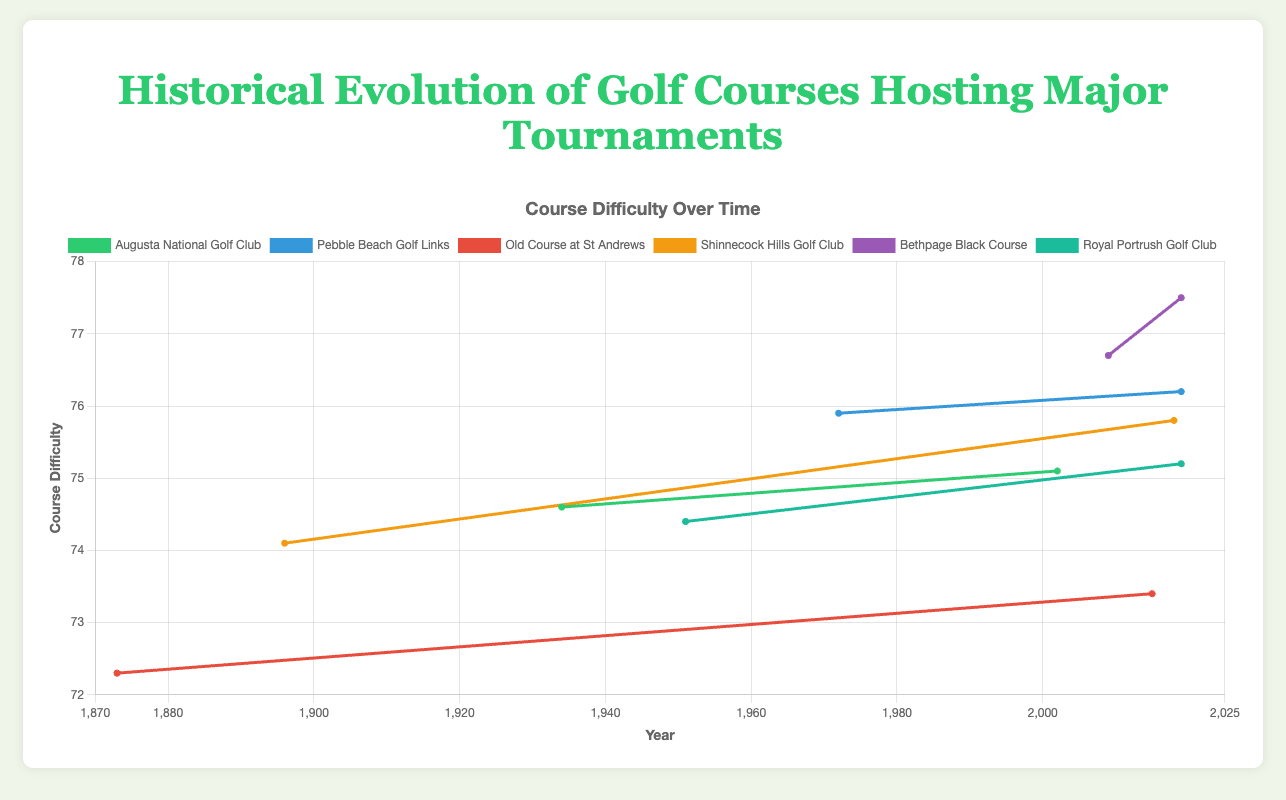What's the average course difficulty of Pebble Beach Golf Links in the years shown? There are two measurements shown for Pebble Beach Golf Links, one in 1972 (75.9) and one in 2019 (76.2). The average is calculated as (75.9 + 76.2) / 2 = 76.05
Answer: 76.05 Which golf course has the highest course difficulty in the data presented? Reviewing the course difficulties of all the courses shown, Bethpage Black Course in 2019 has the highest difficulty with a value of 77.5.
Answer: Bethpage Black Course Between Augusta National Golf Club and Old Course at St Andrews, which had a greater increase in course difficulty between the earliest and latest years shown? For Augusta National: Earliest year shown is 1934 (74.6) and latest is 2002 (75.1). Increase = 75.1 - 74.6 = 0.5; For Old Course: Earliest year shown is 1873 (72.3) and latest is 2015 (73.4). Increase = 73.4 - 72.3 = 1.1. Old Course had a greater increase.
Answer: Old Course at St Andrews How many renovations occurred for courses hosting the U.S. Open between 2000 and 2020? Reviewing the dataset: Pebble Beach (2018), Shinnecock Hills (2016), and Bethpage Black (2007) had renovations in this timeline. This totals to 3 renovations.
Answer: 3 In what year did the Old Course at St Andrews undergo renovation and host The Open Championship in the same year? Reviewing the dataset, the Old Course at St Andrews hosted The Open in 2015, but was last renovated in 2012, so no such year exists where both events occurred in the same year.
Answer: None Which tournament held on Augusta National Golf Club had a higher course difficulty: The Masters in 1934 or 2002? Comparing the course difficulties: The Masters in 1934 had a difficulty of 74.6, and in 2002, it had a difficulty of 75.1. The 2002 tournament had a higher difficulty.
Answer: 2002 